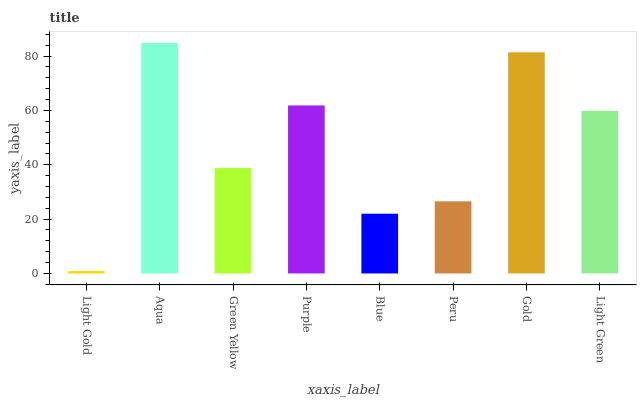Is Light Gold the minimum?
Answer yes or no. Yes. Is Aqua the maximum?
Answer yes or no. Yes. Is Green Yellow the minimum?
Answer yes or no. No. Is Green Yellow the maximum?
Answer yes or no. No. Is Aqua greater than Green Yellow?
Answer yes or no. Yes. Is Green Yellow less than Aqua?
Answer yes or no. Yes. Is Green Yellow greater than Aqua?
Answer yes or no. No. Is Aqua less than Green Yellow?
Answer yes or no. No. Is Light Green the high median?
Answer yes or no. Yes. Is Green Yellow the low median?
Answer yes or no. Yes. Is Blue the high median?
Answer yes or no. No. Is Blue the low median?
Answer yes or no. No. 